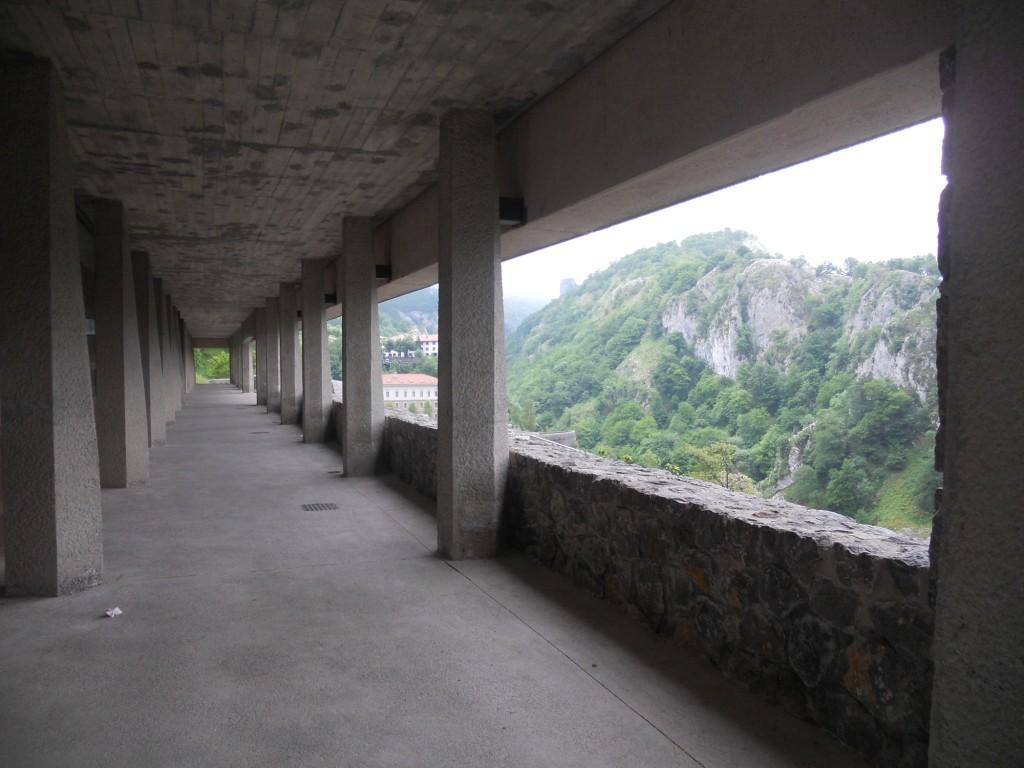What type of structure is visible on the left side of the image? There are pillars of a building on the left side of the image. What natural feature is present on the right side of the image? There are trees on a mountain on the right side of the image. What type of board is being used for the selection process in the image? There is no board or selection process present in the image. 